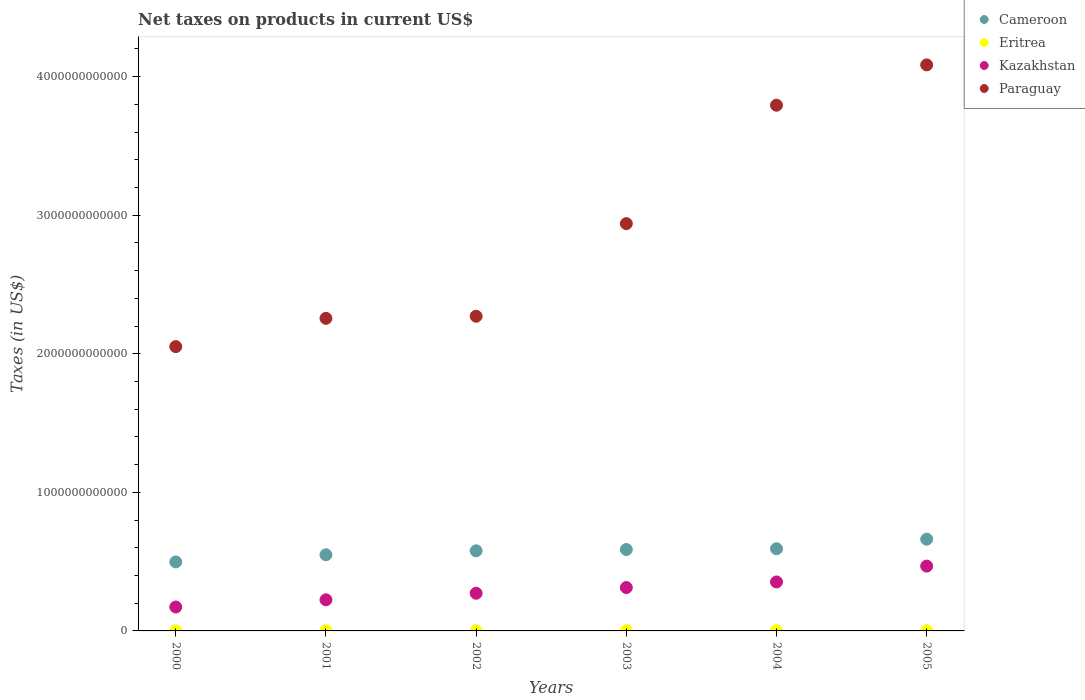How many different coloured dotlines are there?
Your answer should be very brief. 4. Is the number of dotlines equal to the number of legend labels?
Provide a succinct answer. Yes. What is the net taxes on products in Eritrea in 2002?
Provide a succinct answer. 9.85e+08. Across all years, what is the maximum net taxes on products in Kazakhstan?
Ensure brevity in your answer.  4.68e+11. Across all years, what is the minimum net taxes on products in Cameroon?
Offer a very short reply. 4.98e+11. In which year was the net taxes on products in Kazakhstan maximum?
Your answer should be compact. 2005. In which year was the net taxes on products in Eritrea minimum?
Provide a short and direct response. 2000. What is the total net taxes on products in Paraguay in the graph?
Provide a short and direct response. 1.74e+13. What is the difference between the net taxes on products in Kazakhstan in 2002 and that in 2005?
Make the answer very short. -1.96e+11. What is the difference between the net taxes on products in Kazakhstan in 2004 and the net taxes on products in Paraguay in 2002?
Ensure brevity in your answer.  -1.92e+12. What is the average net taxes on products in Paraguay per year?
Your answer should be compact. 2.90e+12. In the year 2003, what is the difference between the net taxes on products in Kazakhstan and net taxes on products in Paraguay?
Your response must be concise. -2.63e+12. In how many years, is the net taxes on products in Paraguay greater than 2600000000000 US$?
Ensure brevity in your answer.  3. What is the ratio of the net taxes on products in Eritrea in 2001 to that in 2002?
Make the answer very short. 0.58. Is the net taxes on products in Cameroon in 2002 less than that in 2003?
Provide a short and direct response. Yes. What is the difference between the highest and the second highest net taxes on products in Cameroon?
Your answer should be very brief. 6.93e+1. What is the difference between the highest and the lowest net taxes on products in Eritrea?
Make the answer very short. 8.05e+08. Is it the case that in every year, the sum of the net taxes on products in Cameroon and net taxes on products in Paraguay  is greater than the sum of net taxes on products in Kazakhstan and net taxes on products in Eritrea?
Make the answer very short. No. Is it the case that in every year, the sum of the net taxes on products in Kazakhstan and net taxes on products in Cameroon  is greater than the net taxes on products in Paraguay?
Give a very brief answer. No. Is the net taxes on products in Kazakhstan strictly greater than the net taxes on products in Paraguay over the years?
Your response must be concise. No. Is the net taxes on products in Kazakhstan strictly less than the net taxes on products in Paraguay over the years?
Your response must be concise. Yes. What is the difference between two consecutive major ticks on the Y-axis?
Make the answer very short. 1.00e+12. How many legend labels are there?
Offer a terse response. 4. What is the title of the graph?
Your response must be concise. Net taxes on products in current US$. What is the label or title of the Y-axis?
Offer a very short reply. Taxes (in US$). What is the Taxes (in US$) of Cameroon in 2000?
Make the answer very short. 4.98e+11. What is the Taxes (in US$) in Eritrea in 2000?
Your answer should be very brief. 4.28e+08. What is the Taxes (in US$) of Kazakhstan in 2000?
Ensure brevity in your answer.  1.73e+11. What is the Taxes (in US$) in Paraguay in 2000?
Provide a succinct answer. 2.05e+12. What is the Taxes (in US$) of Cameroon in 2001?
Keep it short and to the point. 5.49e+11. What is the Taxes (in US$) in Eritrea in 2001?
Provide a short and direct response. 5.68e+08. What is the Taxes (in US$) in Kazakhstan in 2001?
Offer a terse response. 2.25e+11. What is the Taxes (in US$) of Paraguay in 2001?
Your response must be concise. 2.26e+12. What is the Taxes (in US$) in Cameroon in 2002?
Make the answer very short. 5.78e+11. What is the Taxes (in US$) in Eritrea in 2002?
Your answer should be very brief. 9.85e+08. What is the Taxes (in US$) of Kazakhstan in 2002?
Provide a succinct answer. 2.72e+11. What is the Taxes (in US$) in Paraguay in 2002?
Give a very brief answer. 2.27e+12. What is the Taxes (in US$) in Cameroon in 2003?
Your response must be concise. 5.87e+11. What is the Taxes (in US$) in Eritrea in 2003?
Give a very brief answer. 9.80e+08. What is the Taxes (in US$) in Kazakhstan in 2003?
Give a very brief answer. 3.13e+11. What is the Taxes (in US$) of Paraguay in 2003?
Offer a terse response. 2.94e+12. What is the Taxes (in US$) of Cameroon in 2004?
Your answer should be compact. 5.93e+11. What is the Taxes (in US$) of Eritrea in 2004?
Make the answer very short. 1.23e+09. What is the Taxes (in US$) of Kazakhstan in 2004?
Your response must be concise. 3.53e+11. What is the Taxes (in US$) of Paraguay in 2004?
Your answer should be very brief. 3.79e+12. What is the Taxes (in US$) in Cameroon in 2005?
Your answer should be very brief. 6.62e+11. What is the Taxes (in US$) in Eritrea in 2005?
Provide a succinct answer. 1.12e+09. What is the Taxes (in US$) of Kazakhstan in 2005?
Ensure brevity in your answer.  4.68e+11. What is the Taxes (in US$) in Paraguay in 2005?
Provide a succinct answer. 4.08e+12. Across all years, what is the maximum Taxes (in US$) of Cameroon?
Keep it short and to the point. 6.62e+11. Across all years, what is the maximum Taxes (in US$) in Eritrea?
Make the answer very short. 1.23e+09. Across all years, what is the maximum Taxes (in US$) in Kazakhstan?
Your answer should be compact. 4.68e+11. Across all years, what is the maximum Taxes (in US$) of Paraguay?
Provide a succinct answer. 4.08e+12. Across all years, what is the minimum Taxes (in US$) of Cameroon?
Provide a short and direct response. 4.98e+11. Across all years, what is the minimum Taxes (in US$) in Eritrea?
Ensure brevity in your answer.  4.28e+08. Across all years, what is the minimum Taxes (in US$) of Kazakhstan?
Give a very brief answer. 1.73e+11. Across all years, what is the minimum Taxes (in US$) in Paraguay?
Offer a very short reply. 2.05e+12. What is the total Taxes (in US$) in Cameroon in the graph?
Ensure brevity in your answer.  3.47e+12. What is the total Taxes (in US$) in Eritrea in the graph?
Your response must be concise. 5.32e+09. What is the total Taxes (in US$) in Kazakhstan in the graph?
Give a very brief answer. 1.80e+12. What is the total Taxes (in US$) of Paraguay in the graph?
Give a very brief answer. 1.74e+13. What is the difference between the Taxes (in US$) of Cameroon in 2000 and that in 2001?
Ensure brevity in your answer.  -5.16e+1. What is the difference between the Taxes (in US$) of Eritrea in 2000 and that in 2001?
Your response must be concise. -1.40e+08. What is the difference between the Taxes (in US$) of Kazakhstan in 2000 and that in 2001?
Offer a terse response. -5.19e+1. What is the difference between the Taxes (in US$) in Paraguay in 2000 and that in 2001?
Your response must be concise. -2.04e+11. What is the difference between the Taxes (in US$) of Cameroon in 2000 and that in 2002?
Your response must be concise. -8.03e+1. What is the difference between the Taxes (in US$) in Eritrea in 2000 and that in 2002?
Give a very brief answer. -5.58e+08. What is the difference between the Taxes (in US$) of Kazakhstan in 2000 and that in 2002?
Ensure brevity in your answer.  -9.91e+1. What is the difference between the Taxes (in US$) in Paraguay in 2000 and that in 2002?
Offer a very short reply. -2.19e+11. What is the difference between the Taxes (in US$) in Cameroon in 2000 and that in 2003?
Your answer should be very brief. -8.95e+1. What is the difference between the Taxes (in US$) of Eritrea in 2000 and that in 2003?
Make the answer very short. -5.52e+08. What is the difference between the Taxes (in US$) of Kazakhstan in 2000 and that in 2003?
Your answer should be compact. -1.40e+11. What is the difference between the Taxes (in US$) of Paraguay in 2000 and that in 2003?
Offer a terse response. -8.88e+11. What is the difference between the Taxes (in US$) of Cameroon in 2000 and that in 2004?
Give a very brief answer. -9.49e+1. What is the difference between the Taxes (in US$) in Eritrea in 2000 and that in 2004?
Offer a terse response. -8.05e+08. What is the difference between the Taxes (in US$) in Kazakhstan in 2000 and that in 2004?
Give a very brief answer. -1.81e+11. What is the difference between the Taxes (in US$) of Paraguay in 2000 and that in 2004?
Offer a terse response. -1.74e+12. What is the difference between the Taxes (in US$) in Cameroon in 2000 and that in 2005?
Offer a terse response. -1.64e+11. What is the difference between the Taxes (in US$) in Eritrea in 2000 and that in 2005?
Make the answer very short. -6.94e+08. What is the difference between the Taxes (in US$) in Kazakhstan in 2000 and that in 2005?
Provide a succinct answer. -2.95e+11. What is the difference between the Taxes (in US$) in Paraguay in 2000 and that in 2005?
Ensure brevity in your answer.  -2.03e+12. What is the difference between the Taxes (in US$) in Cameroon in 2001 and that in 2002?
Provide a short and direct response. -2.87e+1. What is the difference between the Taxes (in US$) of Eritrea in 2001 and that in 2002?
Your answer should be compact. -4.17e+08. What is the difference between the Taxes (in US$) in Kazakhstan in 2001 and that in 2002?
Your answer should be compact. -4.72e+1. What is the difference between the Taxes (in US$) of Paraguay in 2001 and that in 2002?
Ensure brevity in your answer.  -1.52e+1. What is the difference between the Taxes (in US$) in Cameroon in 2001 and that in 2003?
Ensure brevity in your answer.  -3.80e+1. What is the difference between the Taxes (in US$) in Eritrea in 2001 and that in 2003?
Your answer should be very brief. -4.12e+08. What is the difference between the Taxes (in US$) in Kazakhstan in 2001 and that in 2003?
Ensure brevity in your answer.  -8.84e+1. What is the difference between the Taxes (in US$) in Paraguay in 2001 and that in 2003?
Keep it short and to the point. -6.84e+11. What is the difference between the Taxes (in US$) of Cameroon in 2001 and that in 2004?
Provide a short and direct response. -4.33e+1. What is the difference between the Taxes (in US$) of Eritrea in 2001 and that in 2004?
Make the answer very short. -6.65e+08. What is the difference between the Taxes (in US$) of Kazakhstan in 2001 and that in 2004?
Give a very brief answer. -1.29e+11. What is the difference between the Taxes (in US$) of Paraguay in 2001 and that in 2004?
Offer a terse response. -1.54e+12. What is the difference between the Taxes (in US$) of Cameroon in 2001 and that in 2005?
Give a very brief answer. -1.13e+11. What is the difference between the Taxes (in US$) of Eritrea in 2001 and that in 2005?
Your response must be concise. -5.54e+08. What is the difference between the Taxes (in US$) of Kazakhstan in 2001 and that in 2005?
Provide a succinct answer. -2.43e+11. What is the difference between the Taxes (in US$) of Paraguay in 2001 and that in 2005?
Your answer should be very brief. -1.83e+12. What is the difference between the Taxes (in US$) of Cameroon in 2002 and that in 2003?
Your answer should be compact. -9.24e+09. What is the difference between the Taxes (in US$) of Eritrea in 2002 and that in 2003?
Provide a succinct answer. 5.50e+06. What is the difference between the Taxes (in US$) in Kazakhstan in 2002 and that in 2003?
Provide a short and direct response. -4.12e+1. What is the difference between the Taxes (in US$) in Paraguay in 2002 and that in 2003?
Your response must be concise. -6.68e+11. What is the difference between the Taxes (in US$) of Cameroon in 2002 and that in 2004?
Offer a terse response. -1.46e+1. What is the difference between the Taxes (in US$) of Eritrea in 2002 and that in 2004?
Your response must be concise. -2.48e+08. What is the difference between the Taxes (in US$) in Kazakhstan in 2002 and that in 2004?
Offer a terse response. -8.15e+1. What is the difference between the Taxes (in US$) of Paraguay in 2002 and that in 2004?
Your response must be concise. -1.52e+12. What is the difference between the Taxes (in US$) of Cameroon in 2002 and that in 2005?
Make the answer very short. -8.39e+1. What is the difference between the Taxes (in US$) of Eritrea in 2002 and that in 2005?
Offer a terse response. -1.37e+08. What is the difference between the Taxes (in US$) of Kazakhstan in 2002 and that in 2005?
Provide a short and direct response. -1.96e+11. What is the difference between the Taxes (in US$) in Paraguay in 2002 and that in 2005?
Your answer should be very brief. -1.81e+12. What is the difference between the Taxes (in US$) in Cameroon in 2003 and that in 2004?
Give a very brief answer. -5.34e+09. What is the difference between the Taxes (in US$) in Eritrea in 2003 and that in 2004?
Make the answer very short. -2.53e+08. What is the difference between the Taxes (in US$) of Kazakhstan in 2003 and that in 2004?
Offer a terse response. -4.03e+1. What is the difference between the Taxes (in US$) in Paraguay in 2003 and that in 2004?
Give a very brief answer. -8.55e+11. What is the difference between the Taxes (in US$) in Cameroon in 2003 and that in 2005?
Keep it short and to the point. -7.46e+1. What is the difference between the Taxes (in US$) of Eritrea in 2003 and that in 2005?
Your answer should be compact. -1.42e+08. What is the difference between the Taxes (in US$) of Kazakhstan in 2003 and that in 2005?
Offer a very short reply. -1.55e+11. What is the difference between the Taxes (in US$) in Paraguay in 2003 and that in 2005?
Ensure brevity in your answer.  -1.15e+12. What is the difference between the Taxes (in US$) in Cameroon in 2004 and that in 2005?
Provide a short and direct response. -6.93e+1. What is the difference between the Taxes (in US$) of Eritrea in 2004 and that in 2005?
Provide a short and direct response. 1.11e+08. What is the difference between the Taxes (in US$) of Kazakhstan in 2004 and that in 2005?
Offer a very short reply. -1.15e+11. What is the difference between the Taxes (in US$) in Paraguay in 2004 and that in 2005?
Offer a terse response. -2.91e+11. What is the difference between the Taxes (in US$) of Cameroon in 2000 and the Taxes (in US$) of Eritrea in 2001?
Offer a very short reply. 4.97e+11. What is the difference between the Taxes (in US$) in Cameroon in 2000 and the Taxes (in US$) in Kazakhstan in 2001?
Keep it short and to the point. 2.73e+11. What is the difference between the Taxes (in US$) of Cameroon in 2000 and the Taxes (in US$) of Paraguay in 2001?
Give a very brief answer. -1.76e+12. What is the difference between the Taxes (in US$) of Eritrea in 2000 and the Taxes (in US$) of Kazakhstan in 2001?
Provide a short and direct response. -2.24e+11. What is the difference between the Taxes (in US$) of Eritrea in 2000 and the Taxes (in US$) of Paraguay in 2001?
Offer a very short reply. -2.26e+12. What is the difference between the Taxes (in US$) in Kazakhstan in 2000 and the Taxes (in US$) in Paraguay in 2001?
Your response must be concise. -2.08e+12. What is the difference between the Taxes (in US$) in Cameroon in 2000 and the Taxes (in US$) in Eritrea in 2002?
Provide a succinct answer. 4.97e+11. What is the difference between the Taxes (in US$) of Cameroon in 2000 and the Taxes (in US$) of Kazakhstan in 2002?
Give a very brief answer. 2.26e+11. What is the difference between the Taxes (in US$) of Cameroon in 2000 and the Taxes (in US$) of Paraguay in 2002?
Provide a short and direct response. -1.77e+12. What is the difference between the Taxes (in US$) in Eritrea in 2000 and the Taxes (in US$) in Kazakhstan in 2002?
Make the answer very short. -2.71e+11. What is the difference between the Taxes (in US$) in Eritrea in 2000 and the Taxes (in US$) in Paraguay in 2002?
Give a very brief answer. -2.27e+12. What is the difference between the Taxes (in US$) of Kazakhstan in 2000 and the Taxes (in US$) of Paraguay in 2002?
Provide a succinct answer. -2.10e+12. What is the difference between the Taxes (in US$) in Cameroon in 2000 and the Taxes (in US$) in Eritrea in 2003?
Keep it short and to the point. 4.97e+11. What is the difference between the Taxes (in US$) of Cameroon in 2000 and the Taxes (in US$) of Kazakhstan in 2003?
Your answer should be compact. 1.85e+11. What is the difference between the Taxes (in US$) of Cameroon in 2000 and the Taxes (in US$) of Paraguay in 2003?
Offer a terse response. -2.44e+12. What is the difference between the Taxes (in US$) in Eritrea in 2000 and the Taxes (in US$) in Kazakhstan in 2003?
Provide a succinct answer. -3.13e+11. What is the difference between the Taxes (in US$) in Eritrea in 2000 and the Taxes (in US$) in Paraguay in 2003?
Ensure brevity in your answer.  -2.94e+12. What is the difference between the Taxes (in US$) in Kazakhstan in 2000 and the Taxes (in US$) in Paraguay in 2003?
Provide a short and direct response. -2.77e+12. What is the difference between the Taxes (in US$) of Cameroon in 2000 and the Taxes (in US$) of Eritrea in 2004?
Make the answer very short. 4.97e+11. What is the difference between the Taxes (in US$) in Cameroon in 2000 and the Taxes (in US$) in Kazakhstan in 2004?
Your answer should be very brief. 1.45e+11. What is the difference between the Taxes (in US$) in Cameroon in 2000 and the Taxes (in US$) in Paraguay in 2004?
Provide a short and direct response. -3.30e+12. What is the difference between the Taxes (in US$) in Eritrea in 2000 and the Taxes (in US$) in Kazakhstan in 2004?
Your answer should be very brief. -3.53e+11. What is the difference between the Taxes (in US$) in Eritrea in 2000 and the Taxes (in US$) in Paraguay in 2004?
Your answer should be compact. -3.79e+12. What is the difference between the Taxes (in US$) of Kazakhstan in 2000 and the Taxes (in US$) of Paraguay in 2004?
Give a very brief answer. -3.62e+12. What is the difference between the Taxes (in US$) in Cameroon in 2000 and the Taxes (in US$) in Eritrea in 2005?
Provide a short and direct response. 4.97e+11. What is the difference between the Taxes (in US$) of Cameroon in 2000 and the Taxes (in US$) of Kazakhstan in 2005?
Provide a short and direct response. 3.01e+1. What is the difference between the Taxes (in US$) of Cameroon in 2000 and the Taxes (in US$) of Paraguay in 2005?
Offer a terse response. -3.59e+12. What is the difference between the Taxes (in US$) of Eritrea in 2000 and the Taxes (in US$) of Kazakhstan in 2005?
Your answer should be compact. -4.67e+11. What is the difference between the Taxes (in US$) of Eritrea in 2000 and the Taxes (in US$) of Paraguay in 2005?
Keep it short and to the point. -4.08e+12. What is the difference between the Taxes (in US$) in Kazakhstan in 2000 and the Taxes (in US$) in Paraguay in 2005?
Offer a very short reply. -3.91e+12. What is the difference between the Taxes (in US$) in Cameroon in 2001 and the Taxes (in US$) in Eritrea in 2002?
Provide a succinct answer. 5.48e+11. What is the difference between the Taxes (in US$) in Cameroon in 2001 and the Taxes (in US$) in Kazakhstan in 2002?
Your answer should be very brief. 2.78e+11. What is the difference between the Taxes (in US$) of Cameroon in 2001 and the Taxes (in US$) of Paraguay in 2002?
Your answer should be compact. -1.72e+12. What is the difference between the Taxes (in US$) of Eritrea in 2001 and the Taxes (in US$) of Kazakhstan in 2002?
Give a very brief answer. -2.71e+11. What is the difference between the Taxes (in US$) in Eritrea in 2001 and the Taxes (in US$) in Paraguay in 2002?
Make the answer very short. -2.27e+12. What is the difference between the Taxes (in US$) of Kazakhstan in 2001 and the Taxes (in US$) of Paraguay in 2002?
Make the answer very short. -2.05e+12. What is the difference between the Taxes (in US$) in Cameroon in 2001 and the Taxes (in US$) in Eritrea in 2003?
Offer a terse response. 5.48e+11. What is the difference between the Taxes (in US$) of Cameroon in 2001 and the Taxes (in US$) of Kazakhstan in 2003?
Your answer should be very brief. 2.36e+11. What is the difference between the Taxes (in US$) of Cameroon in 2001 and the Taxes (in US$) of Paraguay in 2003?
Keep it short and to the point. -2.39e+12. What is the difference between the Taxes (in US$) of Eritrea in 2001 and the Taxes (in US$) of Kazakhstan in 2003?
Your response must be concise. -3.12e+11. What is the difference between the Taxes (in US$) of Eritrea in 2001 and the Taxes (in US$) of Paraguay in 2003?
Your response must be concise. -2.94e+12. What is the difference between the Taxes (in US$) in Kazakhstan in 2001 and the Taxes (in US$) in Paraguay in 2003?
Provide a succinct answer. -2.71e+12. What is the difference between the Taxes (in US$) in Cameroon in 2001 and the Taxes (in US$) in Eritrea in 2004?
Keep it short and to the point. 5.48e+11. What is the difference between the Taxes (in US$) in Cameroon in 2001 and the Taxes (in US$) in Kazakhstan in 2004?
Make the answer very short. 1.96e+11. What is the difference between the Taxes (in US$) of Cameroon in 2001 and the Taxes (in US$) of Paraguay in 2004?
Your answer should be very brief. -3.24e+12. What is the difference between the Taxes (in US$) in Eritrea in 2001 and the Taxes (in US$) in Kazakhstan in 2004?
Keep it short and to the point. -3.53e+11. What is the difference between the Taxes (in US$) of Eritrea in 2001 and the Taxes (in US$) of Paraguay in 2004?
Offer a very short reply. -3.79e+12. What is the difference between the Taxes (in US$) in Kazakhstan in 2001 and the Taxes (in US$) in Paraguay in 2004?
Offer a terse response. -3.57e+12. What is the difference between the Taxes (in US$) of Cameroon in 2001 and the Taxes (in US$) of Eritrea in 2005?
Ensure brevity in your answer.  5.48e+11. What is the difference between the Taxes (in US$) of Cameroon in 2001 and the Taxes (in US$) of Kazakhstan in 2005?
Give a very brief answer. 8.16e+1. What is the difference between the Taxes (in US$) of Cameroon in 2001 and the Taxes (in US$) of Paraguay in 2005?
Provide a succinct answer. -3.54e+12. What is the difference between the Taxes (in US$) in Eritrea in 2001 and the Taxes (in US$) in Kazakhstan in 2005?
Give a very brief answer. -4.67e+11. What is the difference between the Taxes (in US$) of Eritrea in 2001 and the Taxes (in US$) of Paraguay in 2005?
Give a very brief answer. -4.08e+12. What is the difference between the Taxes (in US$) of Kazakhstan in 2001 and the Taxes (in US$) of Paraguay in 2005?
Keep it short and to the point. -3.86e+12. What is the difference between the Taxes (in US$) of Cameroon in 2002 and the Taxes (in US$) of Eritrea in 2003?
Provide a short and direct response. 5.77e+11. What is the difference between the Taxes (in US$) in Cameroon in 2002 and the Taxes (in US$) in Kazakhstan in 2003?
Provide a short and direct response. 2.65e+11. What is the difference between the Taxes (in US$) of Cameroon in 2002 and the Taxes (in US$) of Paraguay in 2003?
Keep it short and to the point. -2.36e+12. What is the difference between the Taxes (in US$) of Eritrea in 2002 and the Taxes (in US$) of Kazakhstan in 2003?
Offer a terse response. -3.12e+11. What is the difference between the Taxes (in US$) of Eritrea in 2002 and the Taxes (in US$) of Paraguay in 2003?
Keep it short and to the point. -2.94e+12. What is the difference between the Taxes (in US$) in Kazakhstan in 2002 and the Taxes (in US$) in Paraguay in 2003?
Make the answer very short. -2.67e+12. What is the difference between the Taxes (in US$) of Cameroon in 2002 and the Taxes (in US$) of Eritrea in 2004?
Offer a terse response. 5.77e+11. What is the difference between the Taxes (in US$) in Cameroon in 2002 and the Taxes (in US$) in Kazakhstan in 2004?
Your answer should be very brief. 2.25e+11. What is the difference between the Taxes (in US$) in Cameroon in 2002 and the Taxes (in US$) in Paraguay in 2004?
Keep it short and to the point. -3.22e+12. What is the difference between the Taxes (in US$) of Eritrea in 2002 and the Taxes (in US$) of Kazakhstan in 2004?
Your answer should be very brief. -3.52e+11. What is the difference between the Taxes (in US$) in Eritrea in 2002 and the Taxes (in US$) in Paraguay in 2004?
Give a very brief answer. -3.79e+12. What is the difference between the Taxes (in US$) of Kazakhstan in 2002 and the Taxes (in US$) of Paraguay in 2004?
Your response must be concise. -3.52e+12. What is the difference between the Taxes (in US$) of Cameroon in 2002 and the Taxes (in US$) of Eritrea in 2005?
Your response must be concise. 5.77e+11. What is the difference between the Taxes (in US$) of Cameroon in 2002 and the Taxes (in US$) of Kazakhstan in 2005?
Keep it short and to the point. 1.10e+11. What is the difference between the Taxes (in US$) of Cameroon in 2002 and the Taxes (in US$) of Paraguay in 2005?
Your answer should be very brief. -3.51e+12. What is the difference between the Taxes (in US$) of Eritrea in 2002 and the Taxes (in US$) of Kazakhstan in 2005?
Provide a short and direct response. -4.67e+11. What is the difference between the Taxes (in US$) in Eritrea in 2002 and the Taxes (in US$) in Paraguay in 2005?
Your answer should be compact. -4.08e+12. What is the difference between the Taxes (in US$) in Kazakhstan in 2002 and the Taxes (in US$) in Paraguay in 2005?
Offer a terse response. -3.81e+12. What is the difference between the Taxes (in US$) in Cameroon in 2003 and the Taxes (in US$) in Eritrea in 2004?
Give a very brief answer. 5.86e+11. What is the difference between the Taxes (in US$) of Cameroon in 2003 and the Taxes (in US$) of Kazakhstan in 2004?
Provide a succinct answer. 2.34e+11. What is the difference between the Taxes (in US$) in Cameroon in 2003 and the Taxes (in US$) in Paraguay in 2004?
Keep it short and to the point. -3.21e+12. What is the difference between the Taxes (in US$) in Eritrea in 2003 and the Taxes (in US$) in Kazakhstan in 2004?
Offer a very short reply. -3.52e+11. What is the difference between the Taxes (in US$) in Eritrea in 2003 and the Taxes (in US$) in Paraguay in 2004?
Offer a terse response. -3.79e+12. What is the difference between the Taxes (in US$) in Kazakhstan in 2003 and the Taxes (in US$) in Paraguay in 2004?
Your answer should be compact. -3.48e+12. What is the difference between the Taxes (in US$) in Cameroon in 2003 and the Taxes (in US$) in Eritrea in 2005?
Provide a short and direct response. 5.86e+11. What is the difference between the Taxes (in US$) in Cameroon in 2003 and the Taxes (in US$) in Kazakhstan in 2005?
Offer a terse response. 1.20e+11. What is the difference between the Taxes (in US$) in Cameroon in 2003 and the Taxes (in US$) in Paraguay in 2005?
Offer a terse response. -3.50e+12. What is the difference between the Taxes (in US$) of Eritrea in 2003 and the Taxes (in US$) of Kazakhstan in 2005?
Your answer should be very brief. -4.67e+11. What is the difference between the Taxes (in US$) of Eritrea in 2003 and the Taxes (in US$) of Paraguay in 2005?
Keep it short and to the point. -4.08e+12. What is the difference between the Taxes (in US$) of Kazakhstan in 2003 and the Taxes (in US$) of Paraguay in 2005?
Your answer should be compact. -3.77e+12. What is the difference between the Taxes (in US$) of Cameroon in 2004 and the Taxes (in US$) of Eritrea in 2005?
Keep it short and to the point. 5.92e+11. What is the difference between the Taxes (in US$) of Cameroon in 2004 and the Taxes (in US$) of Kazakhstan in 2005?
Offer a very short reply. 1.25e+11. What is the difference between the Taxes (in US$) in Cameroon in 2004 and the Taxes (in US$) in Paraguay in 2005?
Provide a short and direct response. -3.49e+12. What is the difference between the Taxes (in US$) in Eritrea in 2004 and the Taxes (in US$) in Kazakhstan in 2005?
Your answer should be very brief. -4.67e+11. What is the difference between the Taxes (in US$) of Eritrea in 2004 and the Taxes (in US$) of Paraguay in 2005?
Ensure brevity in your answer.  -4.08e+12. What is the difference between the Taxes (in US$) in Kazakhstan in 2004 and the Taxes (in US$) in Paraguay in 2005?
Make the answer very short. -3.73e+12. What is the average Taxes (in US$) of Cameroon per year?
Offer a very short reply. 5.78e+11. What is the average Taxes (in US$) in Eritrea per year?
Keep it short and to the point. 8.86e+08. What is the average Taxes (in US$) of Kazakhstan per year?
Your response must be concise. 3.01e+11. What is the average Taxes (in US$) of Paraguay per year?
Offer a very short reply. 2.90e+12. In the year 2000, what is the difference between the Taxes (in US$) of Cameroon and Taxes (in US$) of Eritrea?
Your response must be concise. 4.97e+11. In the year 2000, what is the difference between the Taxes (in US$) in Cameroon and Taxes (in US$) in Kazakhstan?
Provide a succinct answer. 3.25e+11. In the year 2000, what is the difference between the Taxes (in US$) of Cameroon and Taxes (in US$) of Paraguay?
Your answer should be very brief. -1.55e+12. In the year 2000, what is the difference between the Taxes (in US$) of Eritrea and Taxes (in US$) of Kazakhstan?
Keep it short and to the point. -1.72e+11. In the year 2000, what is the difference between the Taxes (in US$) in Eritrea and Taxes (in US$) in Paraguay?
Provide a succinct answer. -2.05e+12. In the year 2000, what is the difference between the Taxes (in US$) of Kazakhstan and Taxes (in US$) of Paraguay?
Your answer should be very brief. -1.88e+12. In the year 2001, what is the difference between the Taxes (in US$) in Cameroon and Taxes (in US$) in Eritrea?
Make the answer very short. 5.49e+11. In the year 2001, what is the difference between the Taxes (in US$) of Cameroon and Taxes (in US$) of Kazakhstan?
Ensure brevity in your answer.  3.25e+11. In the year 2001, what is the difference between the Taxes (in US$) of Cameroon and Taxes (in US$) of Paraguay?
Provide a short and direct response. -1.71e+12. In the year 2001, what is the difference between the Taxes (in US$) of Eritrea and Taxes (in US$) of Kazakhstan?
Keep it short and to the point. -2.24e+11. In the year 2001, what is the difference between the Taxes (in US$) of Eritrea and Taxes (in US$) of Paraguay?
Your answer should be very brief. -2.26e+12. In the year 2001, what is the difference between the Taxes (in US$) of Kazakhstan and Taxes (in US$) of Paraguay?
Keep it short and to the point. -2.03e+12. In the year 2002, what is the difference between the Taxes (in US$) in Cameroon and Taxes (in US$) in Eritrea?
Ensure brevity in your answer.  5.77e+11. In the year 2002, what is the difference between the Taxes (in US$) of Cameroon and Taxes (in US$) of Kazakhstan?
Keep it short and to the point. 3.06e+11. In the year 2002, what is the difference between the Taxes (in US$) in Cameroon and Taxes (in US$) in Paraguay?
Provide a short and direct response. -1.69e+12. In the year 2002, what is the difference between the Taxes (in US$) in Eritrea and Taxes (in US$) in Kazakhstan?
Offer a very short reply. -2.71e+11. In the year 2002, what is the difference between the Taxes (in US$) of Eritrea and Taxes (in US$) of Paraguay?
Offer a terse response. -2.27e+12. In the year 2002, what is the difference between the Taxes (in US$) of Kazakhstan and Taxes (in US$) of Paraguay?
Make the answer very short. -2.00e+12. In the year 2003, what is the difference between the Taxes (in US$) in Cameroon and Taxes (in US$) in Eritrea?
Provide a succinct answer. 5.86e+11. In the year 2003, what is the difference between the Taxes (in US$) of Cameroon and Taxes (in US$) of Kazakhstan?
Make the answer very short. 2.74e+11. In the year 2003, what is the difference between the Taxes (in US$) of Cameroon and Taxes (in US$) of Paraguay?
Make the answer very short. -2.35e+12. In the year 2003, what is the difference between the Taxes (in US$) in Eritrea and Taxes (in US$) in Kazakhstan?
Make the answer very short. -3.12e+11. In the year 2003, what is the difference between the Taxes (in US$) in Eritrea and Taxes (in US$) in Paraguay?
Keep it short and to the point. -2.94e+12. In the year 2003, what is the difference between the Taxes (in US$) in Kazakhstan and Taxes (in US$) in Paraguay?
Your answer should be very brief. -2.63e+12. In the year 2004, what is the difference between the Taxes (in US$) in Cameroon and Taxes (in US$) in Eritrea?
Provide a short and direct response. 5.92e+11. In the year 2004, what is the difference between the Taxes (in US$) of Cameroon and Taxes (in US$) of Kazakhstan?
Your answer should be very brief. 2.39e+11. In the year 2004, what is the difference between the Taxes (in US$) in Cameroon and Taxes (in US$) in Paraguay?
Provide a succinct answer. -3.20e+12. In the year 2004, what is the difference between the Taxes (in US$) in Eritrea and Taxes (in US$) in Kazakhstan?
Your response must be concise. -3.52e+11. In the year 2004, what is the difference between the Taxes (in US$) of Eritrea and Taxes (in US$) of Paraguay?
Provide a short and direct response. -3.79e+12. In the year 2004, what is the difference between the Taxes (in US$) of Kazakhstan and Taxes (in US$) of Paraguay?
Your answer should be compact. -3.44e+12. In the year 2005, what is the difference between the Taxes (in US$) in Cameroon and Taxes (in US$) in Eritrea?
Keep it short and to the point. 6.61e+11. In the year 2005, what is the difference between the Taxes (in US$) in Cameroon and Taxes (in US$) in Kazakhstan?
Your answer should be very brief. 1.94e+11. In the year 2005, what is the difference between the Taxes (in US$) in Cameroon and Taxes (in US$) in Paraguay?
Make the answer very short. -3.42e+12. In the year 2005, what is the difference between the Taxes (in US$) in Eritrea and Taxes (in US$) in Kazakhstan?
Your response must be concise. -4.67e+11. In the year 2005, what is the difference between the Taxes (in US$) in Eritrea and Taxes (in US$) in Paraguay?
Offer a terse response. -4.08e+12. In the year 2005, what is the difference between the Taxes (in US$) of Kazakhstan and Taxes (in US$) of Paraguay?
Offer a very short reply. -3.62e+12. What is the ratio of the Taxes (in US$) of Cameroon in 2000 to that in 2001?
Offer a very short reply. 0.91. What is the ratio of the Taxes (in US$) in Eritrea in 2000 to that in 2001?
Keep it short and to the point. 0.75. What is the ratio of the Taxes (in US$) in Kazakhstan in 2000 to that in 2001?
Your answer should be compact. 0.77. What is the ratio of the Taxes (in US$) of Paraguay in 2000 to that in 2001?
Make the answer very short. 0.91. What is the ratio of the Taxes (in US$) of Cameroon in 2000 to that in 2002?
Offer a terse response. 0.86. What is the ratio of the Taxes (in US$) in Eritrea in 2000 to that in 2002?
Your answer should be compact. 0.43. What is the ratio of the Taxes (in US$) in Kazakhstan in 2000 to that in 2002?
Your answer should be compact. 0.64. What is the ratio of the Taxes (in US$) in Paraguay in 2000 to that in 2002?
Your response must be concise. 0.9. What is the ratio of the Taxes (in US$) of Cameroon in 2000 to that in 2003?
Your response must be concise. 0.85. What is the ratio of the Taxes (in US$) of Eritrea in 2000 to that in 2003?
Provide a short and direct response. 0.44. What is the ratio of the Taxes (in US$) in Kazakhstan in 2000 to that in 2003?
Offer a terse response. 0.55. What is the ratio of the Taxes (in US$) in Paraguay in 2000 to that in 2003?
Give a very brief answer. 0.7. What is the ratio of the Taxes (in US$) in Cameroon in 2000 to that in 2004?
Provide a succinct answer. 0.84. What is the ratio of the Taxes (in US$) of Eritrea in 2000 to that in 2004?
Your response must be concise. 0.35. What is the ratio of the Taxes (in US$) of Kazakhstan in 2000 to that in 2004?
Offer a terse response. 0.49. What is the ratio of the Taxes (in US$) of Paraguay in 2000 to that in 2004?
Give a very brief answer. 0.54. What is the ratio of the Taxes (in US$) of Cameroon in 2000 to that in 2005?
Your answer should be very brief. 0.75. What is the ratio of the Taxes (in US$) of Eritrea in 2000 to that in 2005?
Ensure brevity in your answer.  0.38. What is the ratio of the Taxes (in US$) of Kazakhstan in 2000 to that in 2005?
Offer a terse response. 0.37. What is the ratio of the Taxes (in US$) of Paraguay in 2000 to that in 2005?
Provide a short and direct response. 0.5. What is the ratio of the Taxes (in US$) in Cameroon in 2001 to that in 2002?
Offer a terse response. 0.95. What is the ratio of the Taxes (in US$) of Eritrea in 2001 to that in 2002?
Give a very brief answer. 0.58. What is the ratio of the Taxes (in US$) in Kazakhstan in 2001 to that in 2002?
Offer a very short reply. 0.83. What is the ratio of the Taxes (in US$) in Cameroon in 2001 to that in 2003?
Make the answer very short. 0.94. What is the ratio of the Taxes (in US$) of Eritrea in 2001 to that in 2003?
Your answer should be compact. 0.58. What is the ratio of the Taxes (in US$) in Kazakhstan in 2001 to that in 2003?
Provide a succinct answer. 0.72. What is the ratio of the Taxes (in US$) of Paraguay in 2001 to that in 2003?
Your answer should be compact. 0.77. What is the ratio of the Taxes (in US$) in Cameroon in 2001 to that in 2004?
Make the answer very short. 0.93. What is the ratio of the Taxes (in US$) in Eritrea in 2001 to that in 2004?
Offer a terse response. 0.46. What is the ratio of the Taxes (in US$) of Kazakhstan in 2001 to that in 2004?
Your answer should be compact. 0.64. What is the ratio of the Taxes (in US$) of Paraguay in 2001 to that in 2004?
Provide a short and direct response. 0.59. What is the ratio of the Taxes (in US$) in Cameroon in 2001 to that in 2005?
Provide a succinct answer. 0.83. What is the ratio of the Taxes (in US$) of Eritrea in 2001 to that in 2005?
Provide a short and direct response. 0.51. What is the ratio of the Taxes (in US$) in Kazakhstan in 2001 to that in 2005?
Offer a very short reply. 0.48. What is the ratio of the Taxes (in US$) in Paraguay in 2001 to that in 2005?
Give a very brief answer. 0.55. What is the ratio of the Taxes (in US$) of Cameroon in 2002 to that in 2003?
Ensure brevity in your answer.  0.98. What is the ratio of the Taxes (in US$) in Eritrea in 2002 to that in 2003?
Give a very brief answer. 1.01. What is the ratio of the Taxes (in US$) in Kazakhstan in 2002 to that in 2003?
Provide a short and direct response. 0.87. What is the ratio of the Taxes (in US$) in Paraguay in 2002 to that in 2003?
Make the answer very short. 0.77. What is the ratio of the Taxes (in US$) in Cameroon in 2002 to that in 2004?
Provide a succinct answer. 0.98. What is the ratio of the Taxes (in US$) in Eritrea in 2002 to that in 2004?
Make the answer very short. 0.8. What is the ratio of the Taxes (in US$) in Kazakhstan in 2002 to that in 2004?
Your answer should be very brief. 0.77. What is the ratio of the Taxes (in US$) of Paraguay in 2002 to that in 2004?
Your answer should be very brief. 0.6. What is the ratio of the Taxes (in US$) of Cameroon in 2002 to that in 2005?
Give a very brief answer. 0.87. What is the ratio of the Taxes (in US$) in Eritrea in 2002 to that in 2005?
Provide a short and direct response. 0.88. What is the ratio of the Taxes (in US$) in Kazakhstan in 2002 to that in 2005?
Ensure brevity in your answer.  0.58. What is the ratio of the Taxes (in US$) in Paraguay in 2002 to that in 2005?
Provide a short and direct response. 0.56. What is the ratio of the Taxes (in US$) in Eritrea in 2003 to that in 2004?
Keep it short and to the point. 0.79. What is the ratio of the Taxes (in US$) in Kazakhstan in 2003 to that in 2004?
Provide a short and direct response. 0.89. What is the ratio of the Taxes (in US$) of Paraguay in 2003 to that in 2004?
Your answer should be compact. 0.77. What is the ratio of the Taxes (in US$) in Cameroon in 2003 to that in 2005?
Your response must be concise. 0.89. What is the ratio of the Taxes (in US$) of Eritrea in 2003 to that in 2005?
Your answer should be very brief. 0.87. What is the ratio of the Taxes (in US$) of Kazakhstan in 2003 to that in 2005?
Offer a terse response. 0.67. What is the ratio of the Taxes (in US$) of Paraguay in 2003 to that in 2005?
Give a very brief answer. 0.72. What is the ratio of the Taxes (in US$) of Cameroon in 2004 to that in 2005?
Keep it short and to the point. 0.9. What is the ratio of the Taxes (in US$) of Eritrea in 2004 to that in 2005?
Provide a short and direct response. 1.1. What is the ratio of the Taxes (in US$) of Kazakhstan in 2004 to that in 2005?
Your response must be concise. 0.76. What is the ratio of the Taxes (in US$) in Paraguay in 2004 to that in 2005?
Keep it short and to the point. 0.93. What is the difference between the highest and the second highest Taxes (in US$) in Cameroon?
Offer a very short reply. 6.93e+1. What is the difference between the highest and the second highest Taxes (in US$) in Eritrea?
Keep it short and to the point. 1.11e+08. What is the difference between the highest and the second highest Taxes (in US$) in Kazakhstan?
Offer a terse response. 1.15e+11. What is the difference between the highest and the second highest Taxes (in US$) in Paraguay?
Make the answer very short. 2.91e+11. What is the difference between the highest and the lowest Taxes (in US$) of Cameroon?
Provide a succinct answer. 1.64e+11. What is the difference between the highest and the lowest Taxes (in US$) in Eritrea?
Ensure brevity in your answer.  8.05e+08. What is the difference between the highest and the lowest Taxes (in US$) in Kazakhstan?
Offer a terse response. 2.95e+11. What is the difference between the highest and the lowest Taxes (in US$) of Paraguay?
Give a very brief answer. 2.03e+12. 